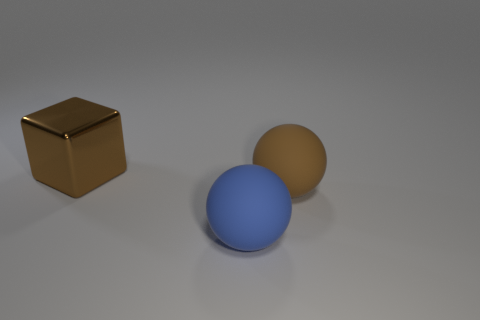Add 1 large red matte blocks. How many objects exist? 4 Subtract all blocks. How many objects are left? 2 Add 2 big cyan cylinders. How many big cyan cylinders exist? 2 Subtract 0 cyan spheres. How many objects are left? 3 Subtract all large blue matte spheres. Subtract all big purple matte cylinders. How many objects are left? 2 Add 3 big shiny cubes. How many big shiny cubes are left? 4 